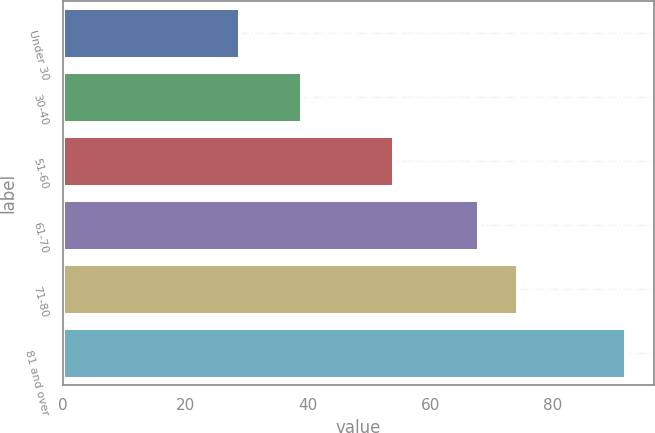<chart> <loc_0><loc_0><loc_500><loc_500><bar_chart><fcel>Under 30<fcel>30-40<fcel>51-60<fcel>61-70<fcel>71-80<fcel>81 and over<nl><fcel>29<fcel>39<fcel>54<fcel>68<fcel>74.3<fcel>92<nl></chart> 